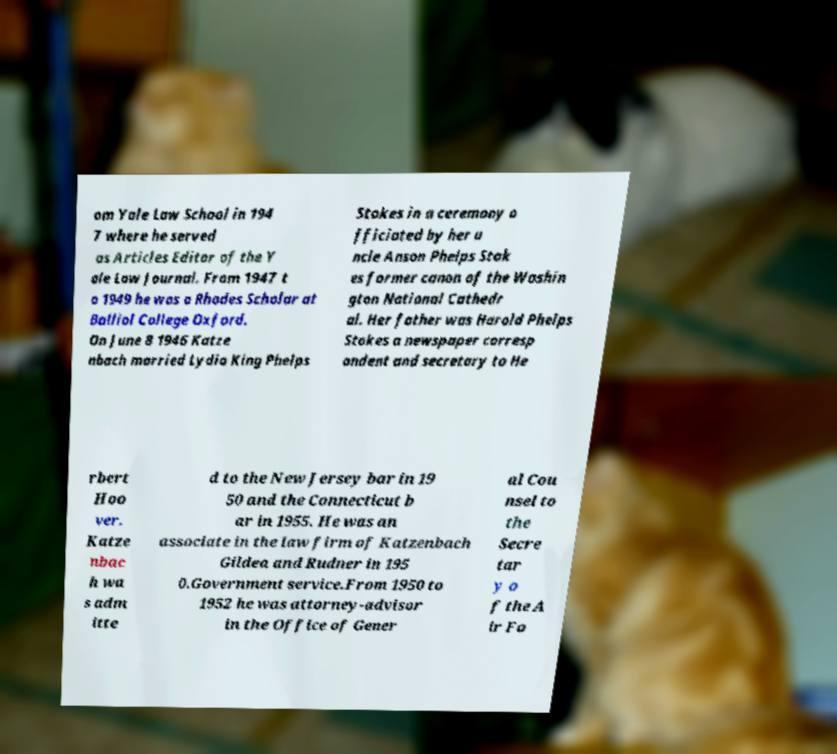Please identify and transcribe the text found in this image. om Yale Law School in 194 7 where he served as Articles Editor of the Y ale Law Journal. From 1947 t o 1949 he was a Rhodes Scholar at Balliol College Oxford. On June 8 1946 Katze nbach married Lydia King Phelps Stokes in a ceremony o fficiated by her u ncle Anson Phelps Stok es former canon of the Washin gton National Cathedr al. Her father was Harold Phelps Stokes a newspaper corresp ondent and secretary to He rbert Hoo ver. Katze nbac h wa s adm itte d to the New Jersey bar in 19 50 and the Connecticut b ar in 1955. He was an associate in the law firm of Katzenbach Gildea and Rudner in 195 0.Government service.From 1950 to 1952 he was attorney-advisor in the Office of Gener al Cou nsel to the Secre tar y o f the A ir Fo 